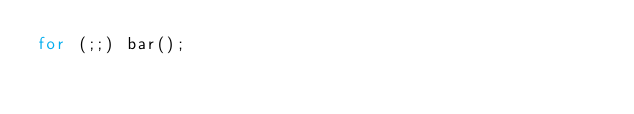<code> <loc_0><loc_0><loc_500><loc_500><_JavaScript_>for (;;) bar();
</code> 